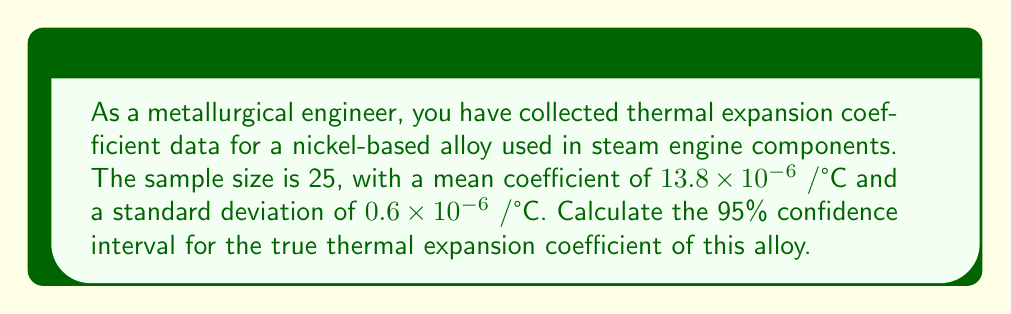Give your solution to this math problem. To calculate the 95% confidence interval, we'll follow these steps:

1) The formula for the confidence interval is:

   $$\bar{x} \pm t_{\alpha/2, n-1} \cdot \frac{s}{\sqrt{n}}$$

   where $\bar{x}$ is the sample mean, $s$ is the sample standard deviation, $n$ is the sample size, and $t_{\alpha/2, n-1}$ is the t-value for a 95% confidence level with $n-1$ degrees of freedom.

2) We have:
   $\bar{x} = 13.8 \times 10^{-6}$ /°C
   $s = 0.6 \times 10^{-6}$ /°C
   $n = 25$

3) For a 95% confidence level and 24 degrees of freedom, $t_{0.025, 24} = 2.064$ (from t-distribution table)

4) Calculate the margin of error:

   $$2.064 \cdot \frac{0.6 \times 10^{-6}}{\sqrt{25}} = 0.2477 \times 10^{-6}$$

5) The confidence interval is:

   $$(13.8 \times 10^{-6}) \pm (0.2477 \times 10^{-6})$$

6) Therefore, the 95% confidence interval is:

   $$(13.5523 \times 10^{-6}, 14.0477 \times 10^{-6})$$ /°C
Answer: $(13.5523 \times 10^{-6}, 14.0477 \times 10^{-6})$ /°C 